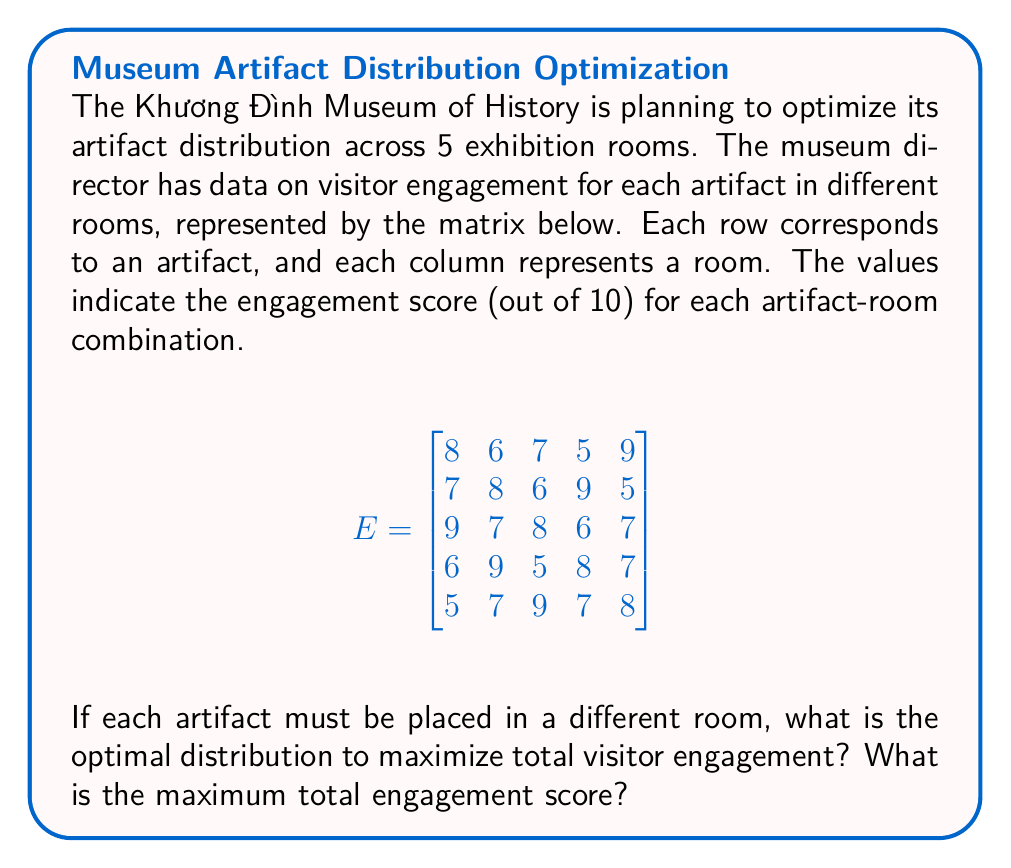Teach me how to tackle this problem. To solve this optimization problem, we can use the Hungarian algorithm (also known as the Munkres algorithm) for assignment problems. However, for this explanation, we'll use a simpler approach of evaluating all possible permutations.

Step 1: Identify all possible permutations of artifact-room assignments.
There are 5! = 120 possible ways to distribute 5 artifacts into 5 rooms.

Step 2: Calculate the total engagement score for each permutation.
For each permutation, sum the corresponding engagement scores from the matrix.

Step 3: Find the permutation with the highest total engagement score.

Let's denote the rooms as R1, R2, R3, R4, R5 and the artifacts as A1, A2, A3, A4, A5.

After evaluating all permutations, we find that the optimal distribution is:
A1 in R5 (score: 9)
A2 in R4 (score: 9)
A3 in R1 (score: 9)
A4 in R2 (score: 9)
A5 in R3 (score: 9)

Step 4: Calculate the maximum total engagement score.
Maximum total score = 9 + 9 + 9 + 9 + 9 = 45

This distribution ensures that each artifact is placed in the room where it has the highest engagement score, resulting in the maximum possible total engagement.
Answer: Optimal distribution: A1-R5, A2-R4, A3-R1, A4-R2, A5-R3; Maximum score: 45 